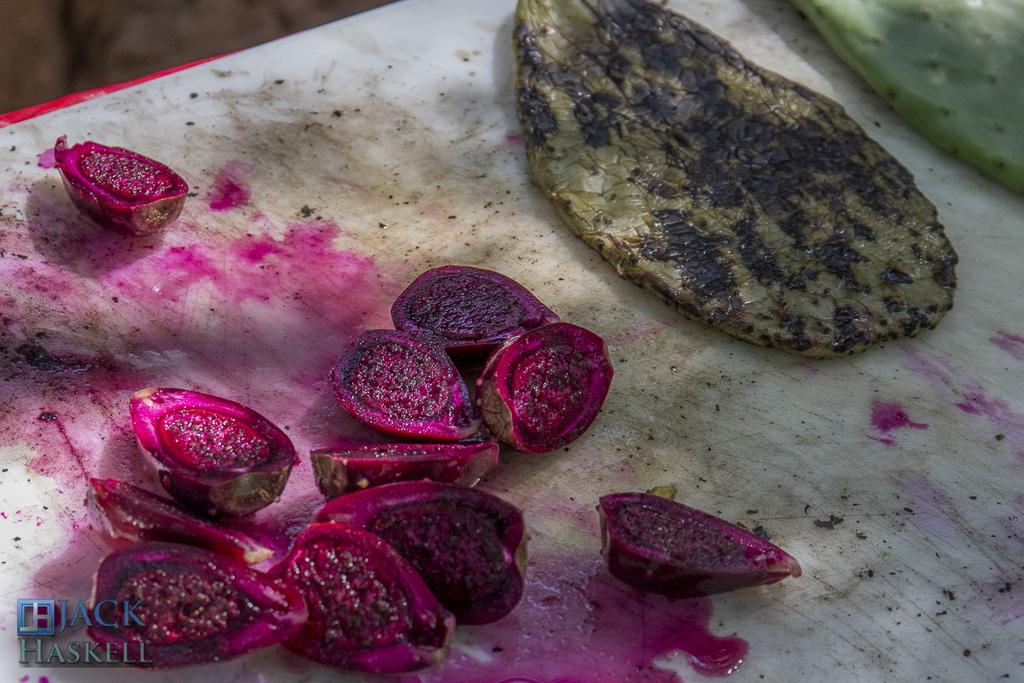What types of food can be seen in the image? There are food items and slices of fruits in the image. Where are the food items and slices of fruits located? They are on a table in the image. What additional information is provided at the bottom of the image? There is some text at the bottom of the image. What is the distance between the yard and the unit in the image? There is no yard or unit present in the image; it only features food items and slices of fruits on a table. 